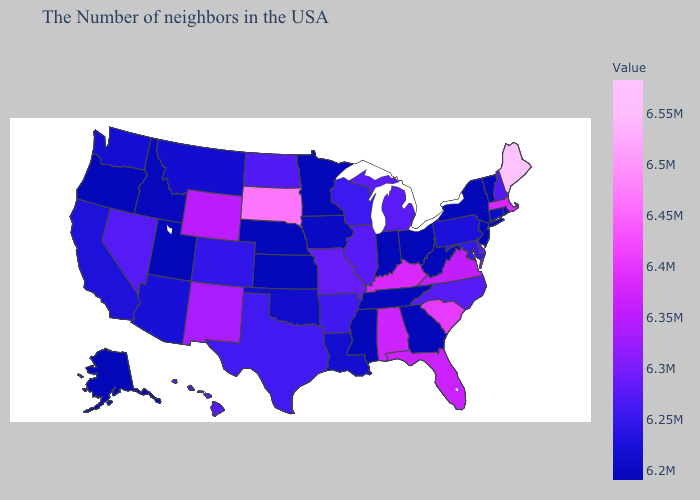Among the states that border Minnesota , which have the highest value?
Keep it brief. South Dakota. Does Louisiana have the lowest value in the South?
Keep it brief. No. Is the legend a continuous bar?
Concise answer only. Yes. Does the map have missing data?
Short answer required. No. Does Colorado have the highest value in the USA?
Answer briefly. No. Among the states that border Arkansas , which have the lowest value?
Give a very brief answer. Tennessee, Mississippi. Does Indiana have the lowest value in the USA?
Be succinct. Yes. Which states have the lowest value in the Northeast?
Keep it brief. Rhode Island, Vermont, New York, New Jersey. Among the states that border New Hampshire , does Massachusetts have the highest value?
Quick response, please. No. Which states have the highest value in the USA?
Write a very short answer. Maine. 